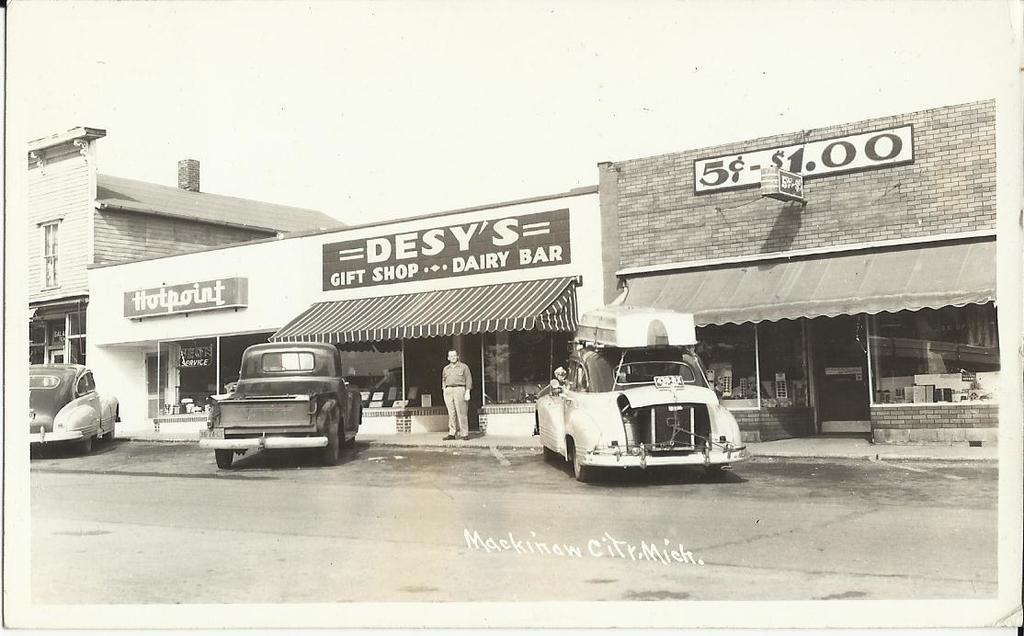Can you describe this image briefly? In this image I can see the road. To the side of the road there are many vehicles and the stalls and also the buildings. There are the boards to the stalls. I can see one person standing in-front of the stall. In the background I can see the sky and this is a black and white image. 